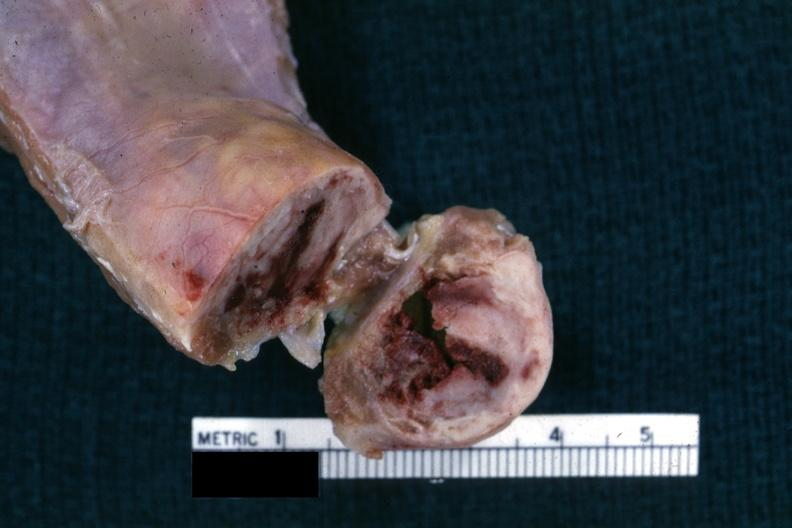what is present?
Answer the question using a single word or phrase. Joints 